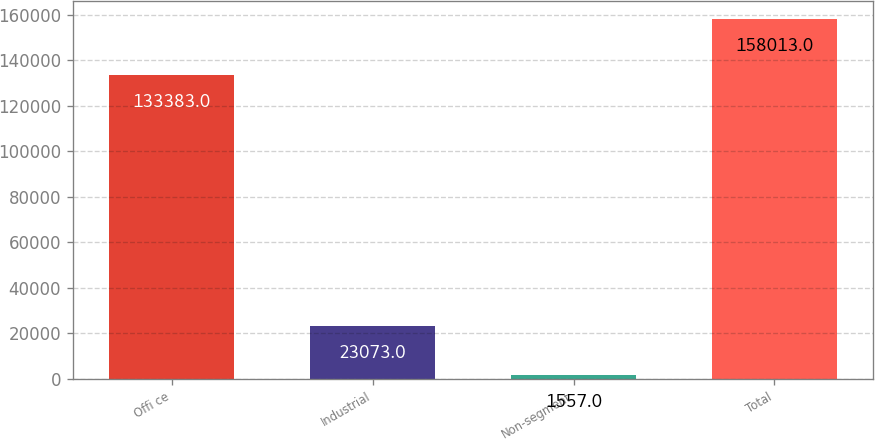Convert chart. <chart><loc_0><loc_0><loc_500><loc_500><bar_chart><fcel>Offi ce<fcel>Industrial<fcel>Non-segment<fcel>Total<nl><fcel>133383<fcel>23073<fcel>1557<fcel>158013<nl></chart> 